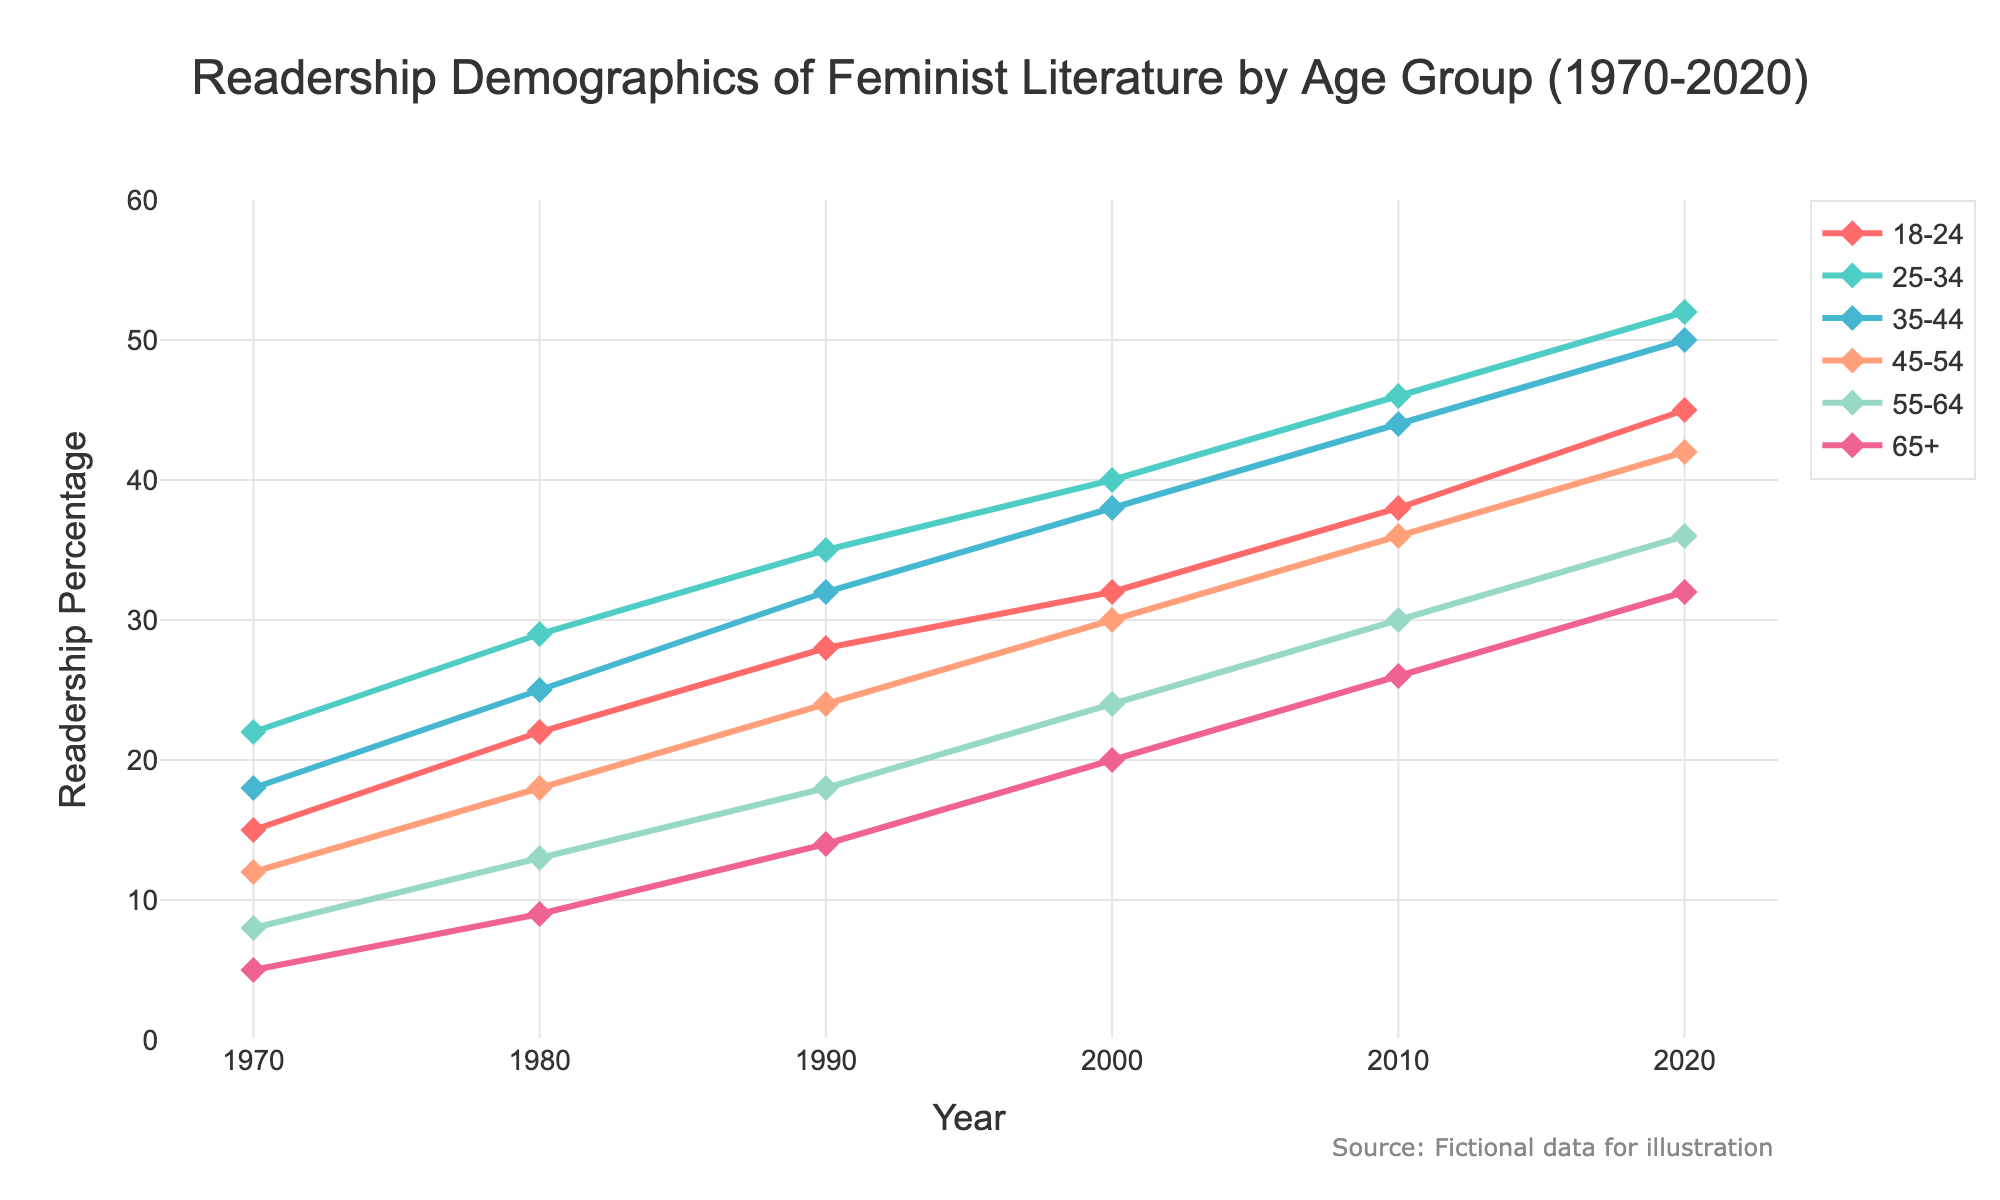What's the average readership percentage for the 25-34 age group from 1970 to 2020? To find the average, sum the percentages for the 25-34 age group across all years: 22 + 29 + 35 + 40 + 46 + 52 = 224. Then divide by the number of data points (6): 224 / 6 = 37.33.
Answer: 37.33 Which age group had the lowest readership percentage in 2000? By examining the values for 2000, the age group with the lowest percentage is 65+, which has a value of 20.
Answer: 65+ By how much did the readership percentage for the 18-24 age group increase from 1970 to 2020? In 1970, the readership percentage for 18-24 was 15. In 2020, it was 45. The increase is found by subtracting the earlier value from the later one: 45 - 15 = 30.
Answer: 30 In which decade did the 55-64 age group show the greatest increase in readership percentage? By comparing the increments: 1970 to 1980 (8 to 13 = 5), 1980 to 1990 (13 to 18 = 5), 1990 to 2000 (18 to 24 = 6), 2000 to 2010 (24 to 30 = 6), and 2010 to 2020 (30 to 36 = 6), the group shows the greatest increase in each of the last three decades: 1990 to 2000, 2000 to 2010, and 2010 to 2020, all with an increase of 6.
Answer: 1990-2000, 2000-2010, and 2010-2020 Which age group shows the most dramatic visual growth across the entire period? Examining the slopes of the lines in the chart, the 18-24 age group shows the steepest increase, growing from 15 in 1970 to 45 in 2020.
Answer: 18-24 What is the difference in readership percentage between the youngest and oldest age groups in 2020? The percentage for the 18-24 age group in 2020 is 45, and for the 65+ age group is 32. The difference is 45 - 32 = 13.
Answer: 13 Which two age groups had equal readership percentages at any point in time? By observing the graph and the values, the 18-24 and 35-44 age groups both had 32% readership in the year 2000.
Answer: 18-24 and 35-44 What is the total readership percentage of all age groups in 1980? Sum the readership percentages for all age groups in 1980: 22 + 29 + 25 + 18 + 13 + 9 = 116.
Answer: 116 Which color represents the 45-54 age group, and how does its readership percentage change over time? The 45-54 age group is represented by the orange color. Its readership percentage increases from 12 in 1970 to 42 in 2020.
Answer: Orange, increased by 30 Among all age groups, who had the highest percentage increase between any two consecutive decades? The highest increase in a single decade is for the 35-44 age group from 1970 to 1980, increasing by 7 from 18 to 25.
Answer: 35-44, 7 